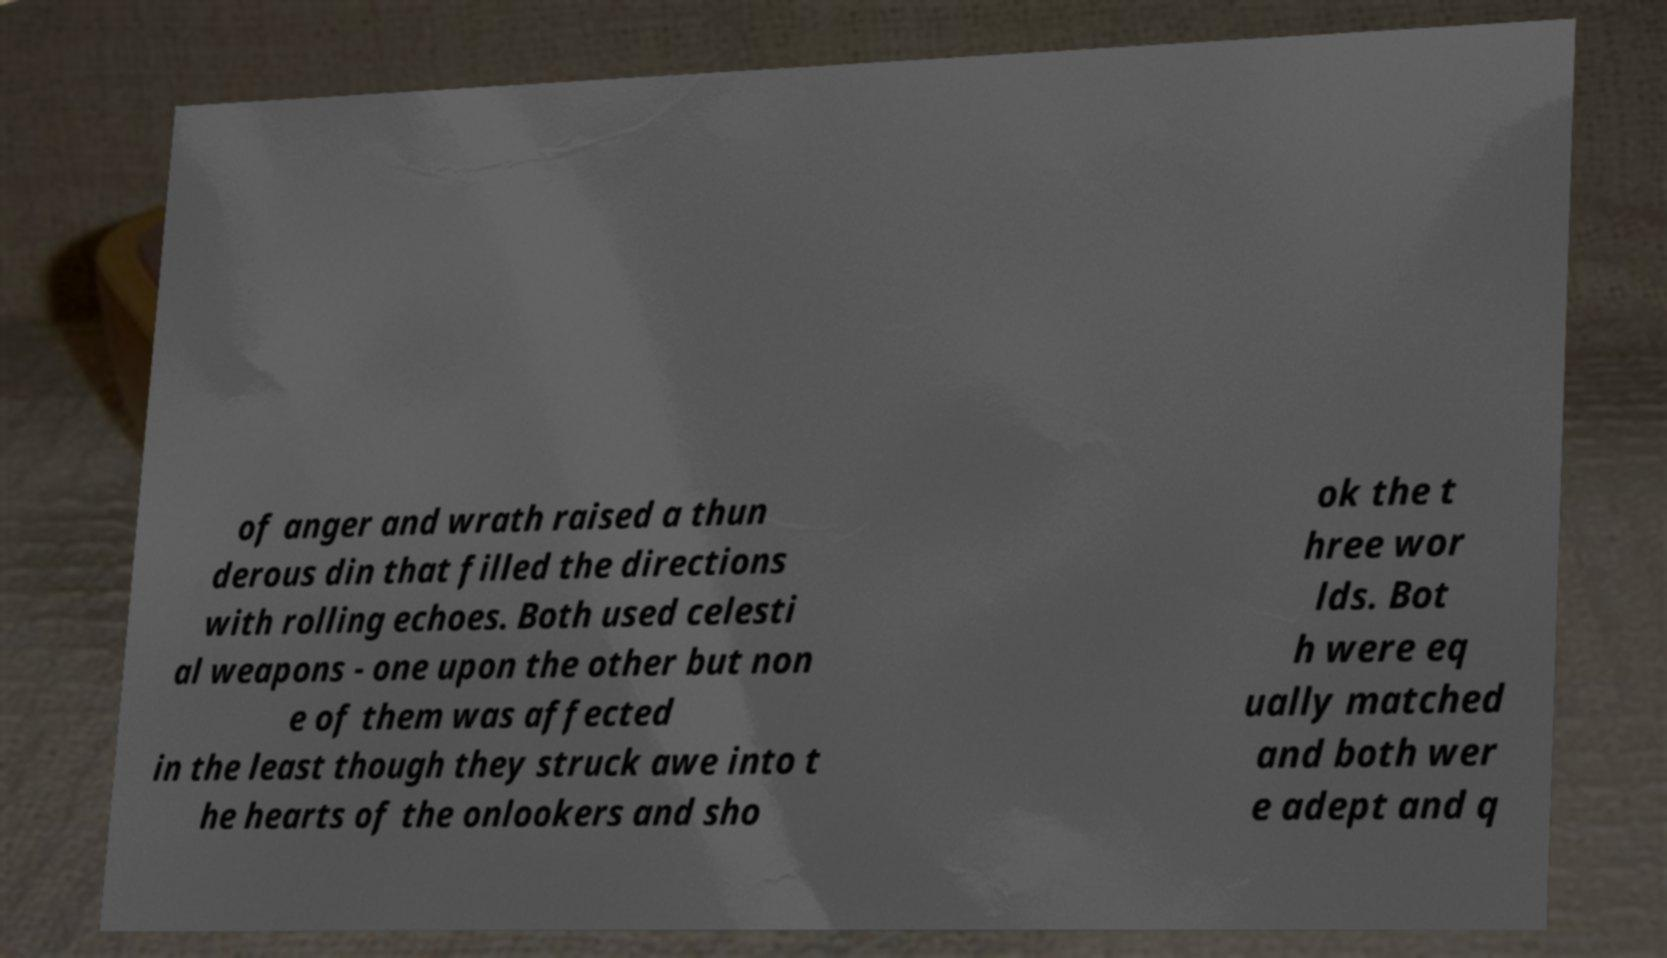Please identify and transcribe the text found in this image. of anger and wrath raised a thun derous din that filled the directions with rolling echoes. Both used celesti al weapons - one upon the other but non e of them was affected in the least though they struck awe into t he hearts of the onlookers and sho ok the t hree wor lds. Bot h were eq ually matched and both wer e adept and q 